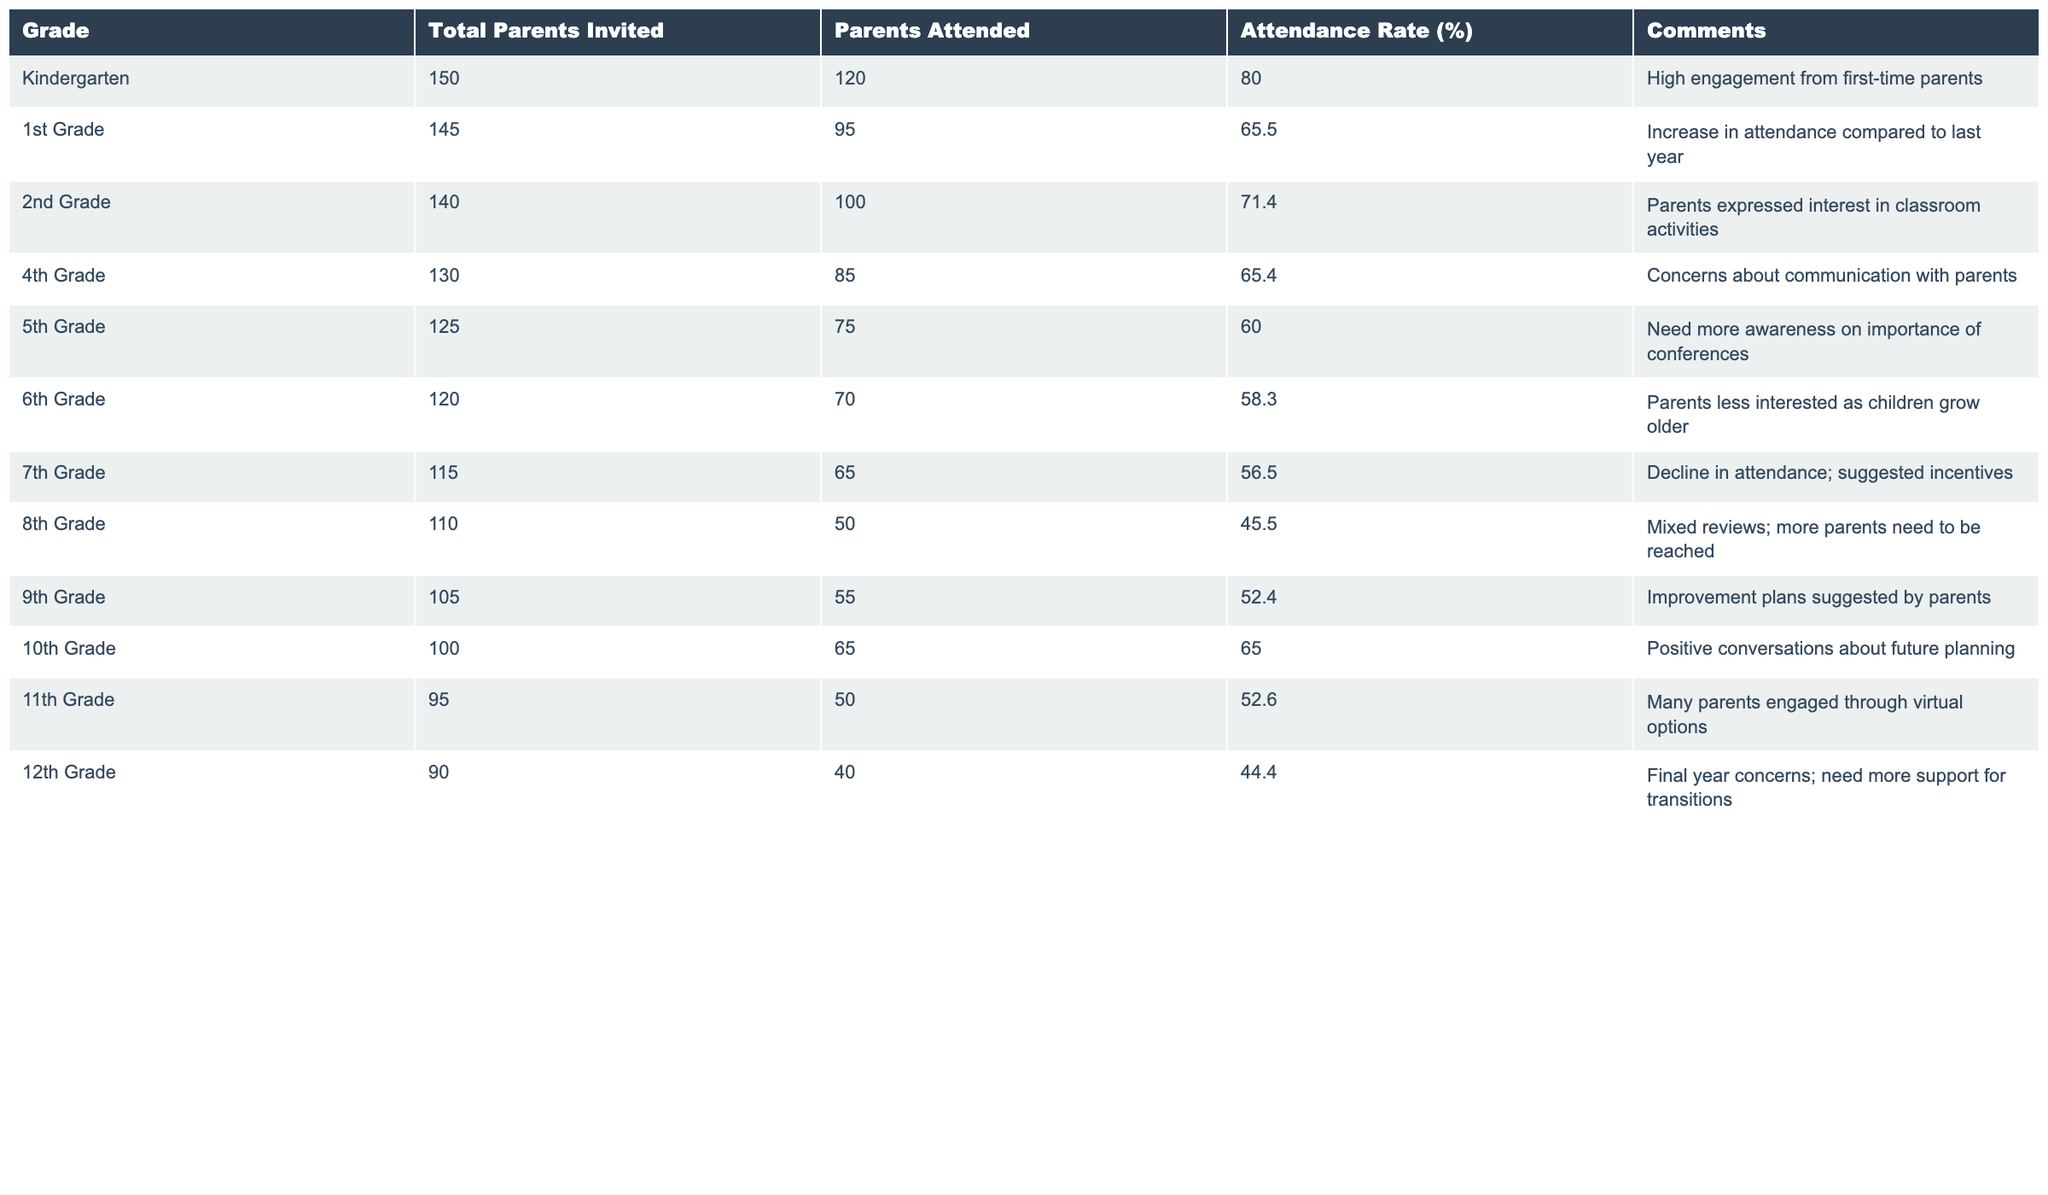What is the attendance rate for Kindergarten? The table shows that the attendance rate for Kindergarten is listed as 80.0%.
Answer: 80.0% How many parents attended the 4th Grade conference? According to the table, 85 parents attended the 4th Grade conference.
Answer: 85 What is the average attendance rate across all grades? To find the average attendance rate, add all attendance rates: (80 + 65.5 + 71.4 + 65.4 + 60 + 58.3 + 56.5 + 45.5 + 52.4 + 65 + 52.6 + 44.4) =  718.3. Then divide by the number of grades (12): 718.3 / 12 = 59.86.
Answer: 59.86 Did the 6th Grade have the lowest attendance rate? The table indicates that the 6th Grade has an attendance rate of 58.3%, which is higher than 8th Grade's rate of 45.5%. Therefore, 8th Grade has the lowest attendance rate.
Answer: No Which grade had the highest percentage of parents attending? By comparing the attendance rates for each grade, it is clear that Kindergarten has the highest attendance rate at 80.0%.
Answer: Kindergarten What is the difference in attendance rates between 2nd Grade and 5th Grade? The attendance rate for 2nd Grade is 71.4%, and for 5th Grade, it is 60.0%. The difference is 71.4 - 60.0 = 11.4%.
Answer: 11.4% How many more parents attended the 1st Grade conference than the 8th Grade? The 1st Grade had 95 parents attend while the 8th Grade had 50. Subtracting gives us 95 - 50 = 45.
Answer: 45 Are parents in higher grades less interested in conferences overall? Examining the data, the attendance rates decline from Kindergarten (80.0%) down to 12th Grade (44.4%), indicating a trend where higher grades have lower attendance.
Answer: Yes What is the total number of parents invited across all grades? Adding up the Total Parents Invited for each grade gives 150 + 145 + 140 + 130 + 125 + 120 + 115 + 110 + 105 + 100 + 95 + 90 = 1,495.
Answer: 1,495 Which grade shows the most significant drop in attendance rate compared to the previous year? By analyzing the table, 8th Grade shows the most drastic drop with an attendance rate of 45.5%, indicating a significant decline in parent attendance. The decline from 8th Grade's previous year is more substantial compared to other grades.
Answer: 8th Grade 